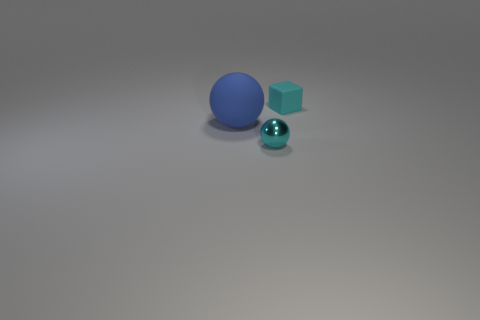Does the tiny block have the same color as the tiny metallic ball?
Give a very brief answer. Yes. Is there anything else that is the same material as the tiny sphere?
Offer a terse response. No. What number of large objects are blue rubber things or shiny objects?
Provide a succinct answer. 1. Is there a gray metallic thing that has the same size as the cyan matte thing?
Your answer should be very brief. No. How many shiny things are tiny blue cylinders or tiny cyan blocks?
Keep it short and to the point. 0. The metallic object that is the same color as the small matte cube is what shape?
Give a very brief answer. Sphere. What number of large gray matte balls are there?
Give a very brief answer. 0. Is the small cyan thing behind the big blue thing made of the same material as the large blue object that is to the left of the rubber block?
Keep it short and to the point. Yes. What size is the blue sphere that is made of the same material as the cube?
Offer a terse response. Large. There is a small thing that is behind the small cyan metallic thing; what is its shape?
Provide a succinct answer. Cube. 